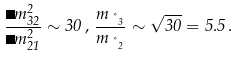<formula> <loc_0><loc_0><loc_500><loc_500>\frac { \Delta m ^ { 2 } _ { 3 2 } } { \Delta m ^ { 2 } _ { 2 1 } } \sim 3 0 \, , \, \frac { m _ { \nu _ { 3 } } } { m _ { \nu _ { 2 } } } \sim \sqrt { 3 0 } = 5 . 5 \, .</formula> 